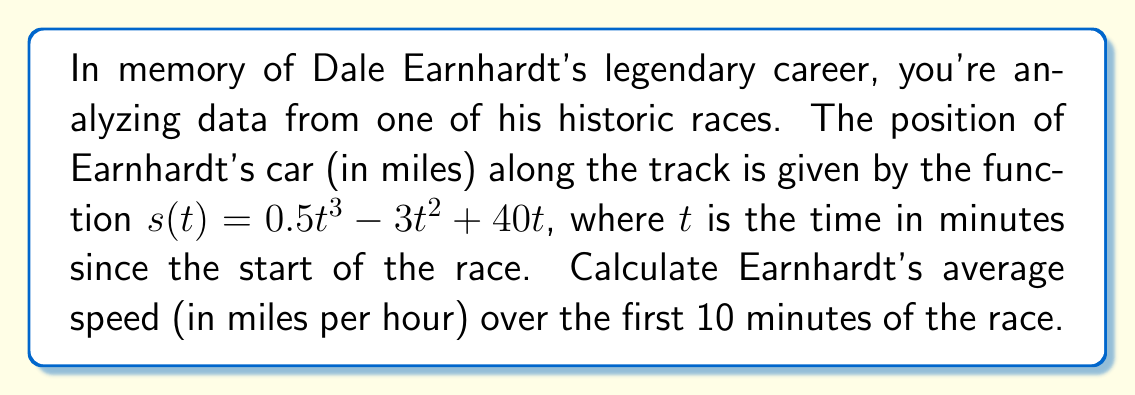Show me your answer to this math problem. To find the average speed, we need to determine the distance traveled and divide it by the time taken.

1) First, let's find the distance traveled:
   - At $t = 0$ minutes: $s(0) = 0.5(0)^3 - 3(0)^2 + 40(0) = 0$ miles
   - At $t = 10$ minutes: $s(10) = 0.5(10)^3 - 3(10)^2 + 40(10)$
                                 $= 500 - 300 + 400 = 600$ miles

   Distance traveled = $600 - 0 = 600$ miles

2) Time taken = 10 minutes = $\frac{1}{6}$ hour

3) Average speed = $\frac{\text{Distance}}{\text{Time}}$
                 $= \frac{600 \text{ miles}}{\frac{1}{6} \text{ hour}}$
                 $= 600 \cdot 6 = 3600$ miles per hour

Therefore, Earnhardt's average speed over the first 10 minutes was 3600 mph.
Answer: 3600 mph 